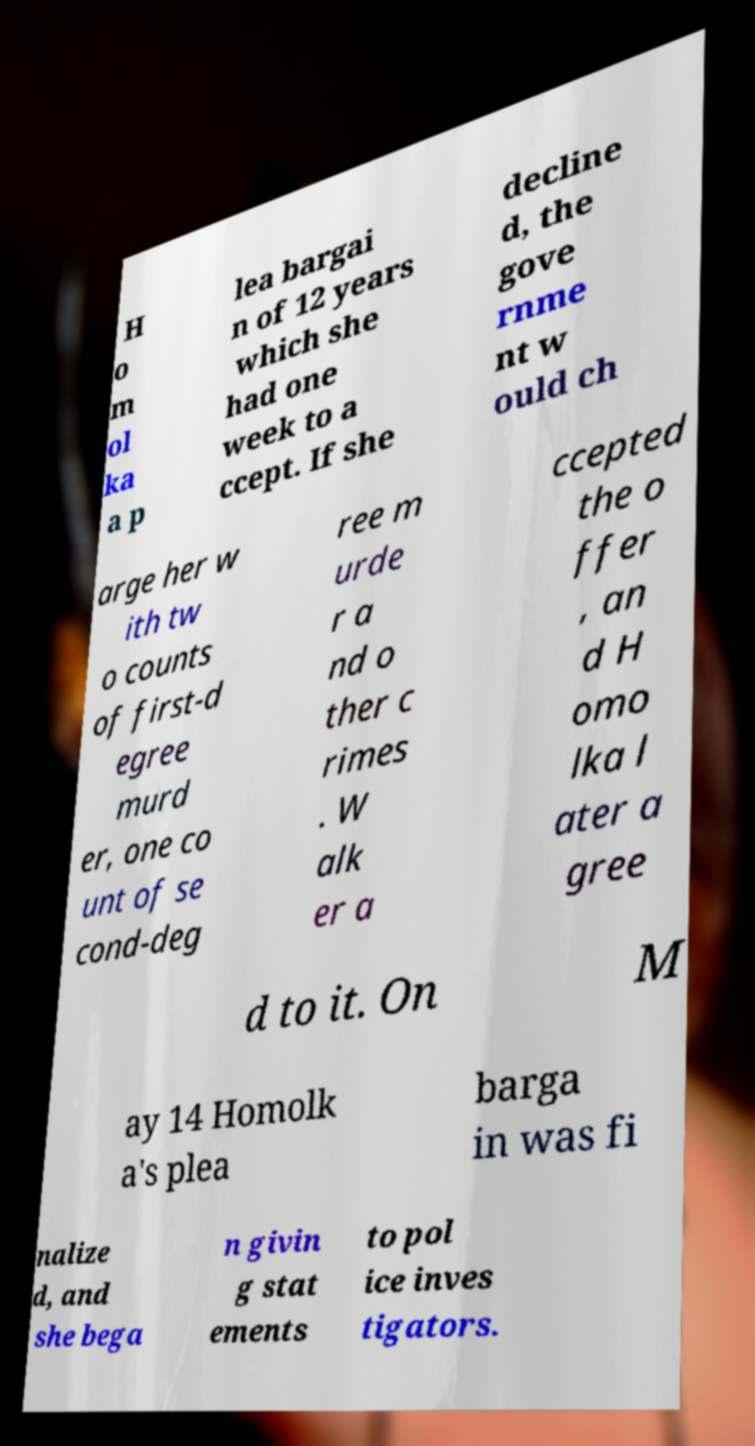Please read and relay the text visible in this image. What does it say? H o m ol ka a p lea bargai n of 12 years which she had one week to a ccept. If she decline d, the gove rnme nt w ould ch arge her w ith tw o counts of first-d egree murd er, one co unt of se cond-deg ree m urde r a nd o ther c rimes . W alk er a ccepted the o ffer , an d H omo lka l ater a gree d to it. On M ay 14 Homolk a's plea barga in was fi nalize d, and she bega n givin g stat ements to pol ice inves tigators. 